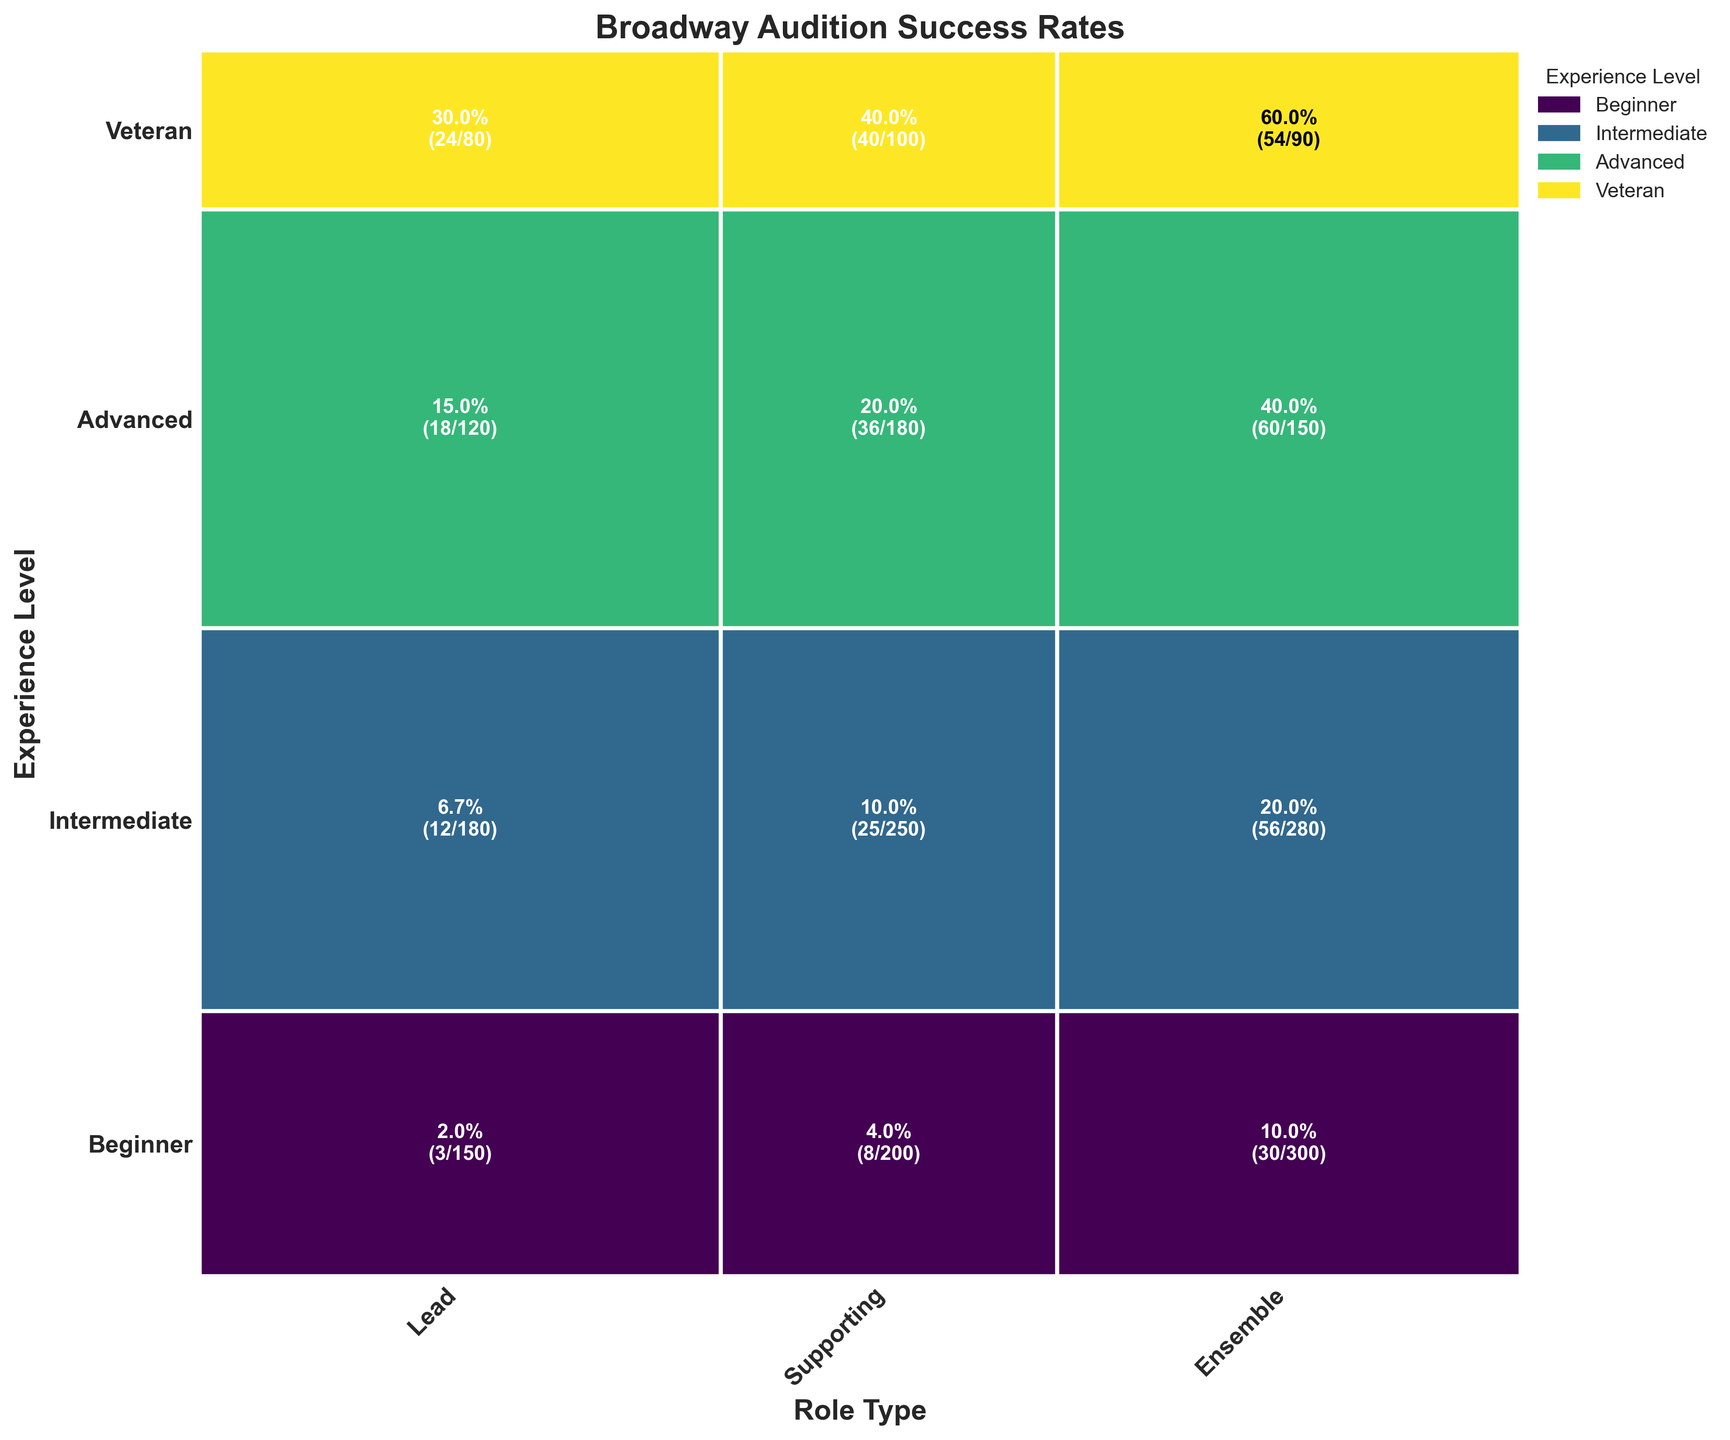How many experience levels are represented in the plot? The y-axis labels show the different experience levels. By counting the distinct labels, we find there are four experience levels: Beginner, Intermediate, Advanced, and Veteran.
Answer: Four Which role type has the highest audition success rate for Beginners? To find this, compare the success rates for each role type in the Beginners row. The success rates are 2% for Lead (3/150), 4% for Supporting (8/200), and 10% for Ensemble (30/300). Ensemble has the highest success rate for Beginners.
Answer: Ensemble What is the total number of successful auditions for Intermediate experience level across all roles? Sum the successful auditions for all roles at the Intermediate level: 12 (Lead) + 25 (Supporting) + 56 (Ensemble) = 93.
Answer: 93 Which experience level has the highest success rate for the Lead role? Compare the success rates for the Lead role across all experience levels. Success rates are: Beginner 2% (3/150), Intermediate 6.7% (12/180), Advanced 15% (18/120), Veteran 30% (24/80). Veteran has the highest success rate for the Lead role.
Answer: Veteran Which role type do Veterans have the highest number of successful auditions in? For Veterans, compare the number of successful auditions across all role types. Values are: Lead 24, Supporting 40, Ensemble 54. Ensemble has the highest number of successful auditions for Veterans.
Answer: Ensemble What is the combined success rate for the Supporting role for all experience levels? Find the total successful auditions and the total number of auditions for the Supporting role across all experience levels. Total successful: 8 (Beginner) + 25 (Intermediate) + 36 (Advanced) + 40 (Veteran) = 109. Total auditioned: 200 + 250 + 180 + 100 = 730. Success rate = 109 / 730 ≈ 14.9%.
Answer: ≈ 14.9% Which experience level has the largest difference in successful auditions between Ensemble and Lead roles? Calculate the differences for each experience level:
Beginner: 30 - 3 = 27,
Intermediate: 56 - 12 = 44,
Advanced: 60 - 18 = 42,
Veteran: 54 - 24 = 30. Intermediate has the largest difference of 44.
Answer: Intermediate How does the success rate for Advanced in the Ensemble role compare to Intermediate in the same role? The success rate for Advanced in Ensemble is 40% (60/150) and for Intermediate in Ensemble is 20% (56/280). Advanced has a success rate twice as high as Intermediate.
Answer: Twice as high What is the average number of auditions for the Supporting role across all experience levels? Total number of auditions for Supporting role: 200 (Beginner) + 250 (Intermediate) + 180 (Advanced) + 100 (Veteran) = 730. Average = 730 / 4 = 182.5.
Answer: 182.5 Which combination of experience level and role type shows the least success rate among all? Look for the lowest success rates among all combinations: Beginner-Lead 2% (3/150), Beginner-Supporting 4% (8/200). The lowest is Beginner in the Lead role at 2%.
Answer: Beginner-Lead 